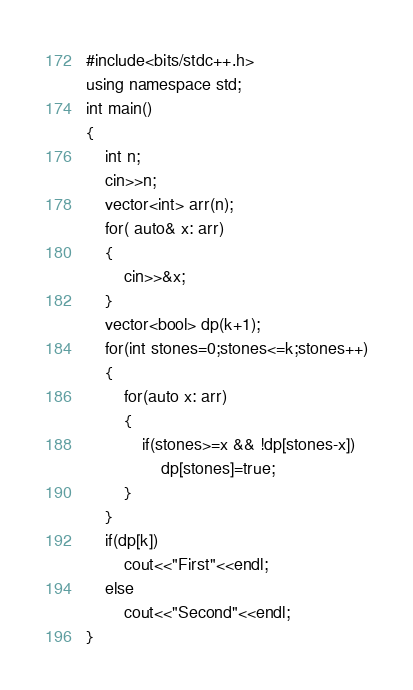<code> <loc_0><loc_0><loc_500><loc_500><_C++_>#include<bits/stdc++.h>
using namespace std;
int main()
{
    int n;
    cin>>n;
    vector<int> arr(n);
    for( auto& x: arr)
    {
        cin>>&x;
    }
    vector<bool> dp(k+1);
    for(int stones=0;stones<=k;stones++)
    {
        for(auto x: arr)
        {
            if(stones>=x && !dp[stones-x])
                dp[stones]=true;
        }
    }
    if(dp[k])
        cout<<"First"<<endl;
    else
        cout<<"Second"<<endl;
}</code> 